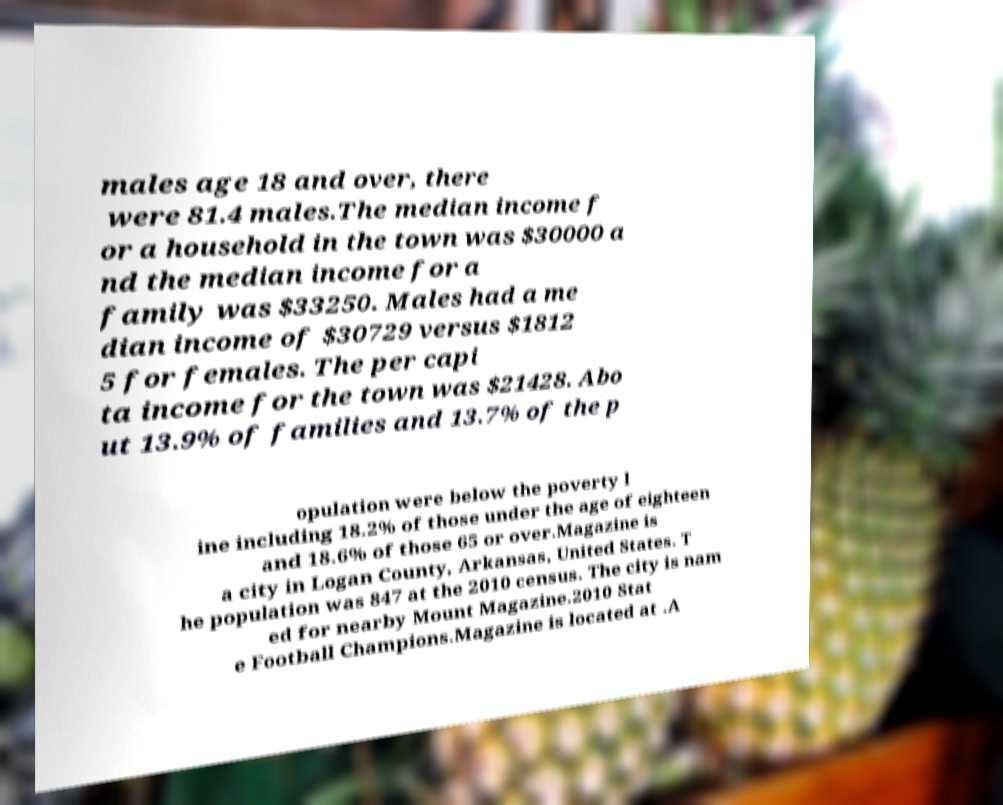There's text embedded in this image that I need extracted. Can you transcribe it verbatim? males age 18 and over, there were 81.4 males.The median income f or a household in the town was $30000 a nd the median income for a family was $33250. Males had a me dian income of $30729 versus $1812 5 for females. The per capi ta income for the town was $21428. Abo ut 13.9% of families and 13.7% of the p opulation were below the poverty l ine including 18.2% of those under the age of eighteen and 18.6% of those 65 or over.Magazine is a city in Logan County, Arkansas, United States. T he population was 847 at the 2010 census. The city is nam ed for nearby Mount Magazine.2010 Stat e Football Champions.Magazine is located at .A 